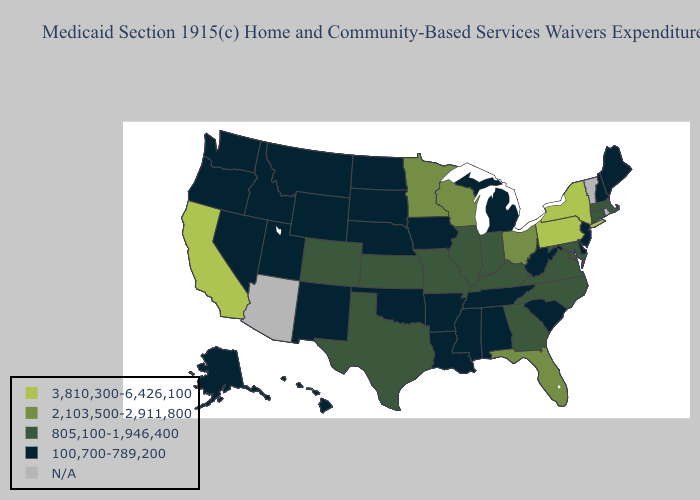Name the states that have a value in the range N/A?
Be succinct. Arizona, Rhode Island, Vermont. Does Georgia have the lowest value in the South?
Short answer required. No. Among the states that border Minnesota , does Iowa have the highest value?
Answer briefly. No. Name the states that have a value in the range 3,810,300-6,426,100?
Give a very brief answer. California, New York, Pennsylvania. Does Alaska have the lowest value in the West?
Be succinct. Yes. Is the legend a continuous bar?
Write a very short answer. No. Does the map have missing data?
Answer briefly. Yes. Which states hav the highest value in the Northeast?
Quick response, please. New York, Pennsylvania. Name the states that have a value in the range 805,100-1,946,400?
Concise answer only. Colorado, Connecticut, Georgia, Illinois, Indiana, Kansas, Kentucky, Maryland, Massachusetts, Missouri, North Carolina, Texas, Virginia. Name the states that have a value in the range N/A?
Quick response, please. Arizona, Rhode Island, Vermont. Is the legend a continuous bar?
Write a very short answer. No. How many symbols are there in the legend?
Short answer required. 5. Among the states that border North Dakota , which have the highest value?
Concise answer only. Minnesota. Which states hav the highest value in the South?
Concise answer only. Florida. 